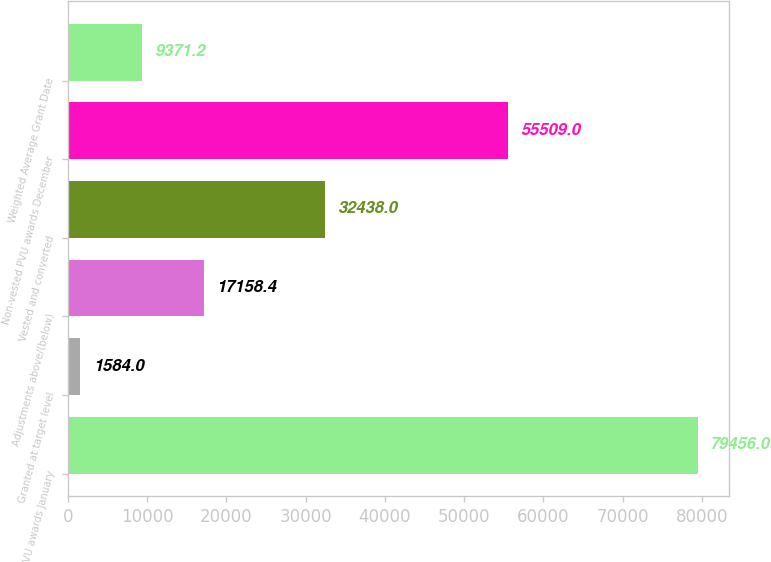Convert chart to OTSL. <chart><loc_0><loc_0><loc_500><loc_500><bar_chart><fcel>Non-vested PVU awards January<fcel>Granted at target level<fcel>Adjustments above/(below)<fcel>Vested and converted<fcel>Non-vested PVU awards December<fcel>Weighted Average Grant Date<nl><fcel>79456<fcel>1584<fcel>17158.4<fcel>32438<fcel>55509<fcel>9371.2<nl></chart> 